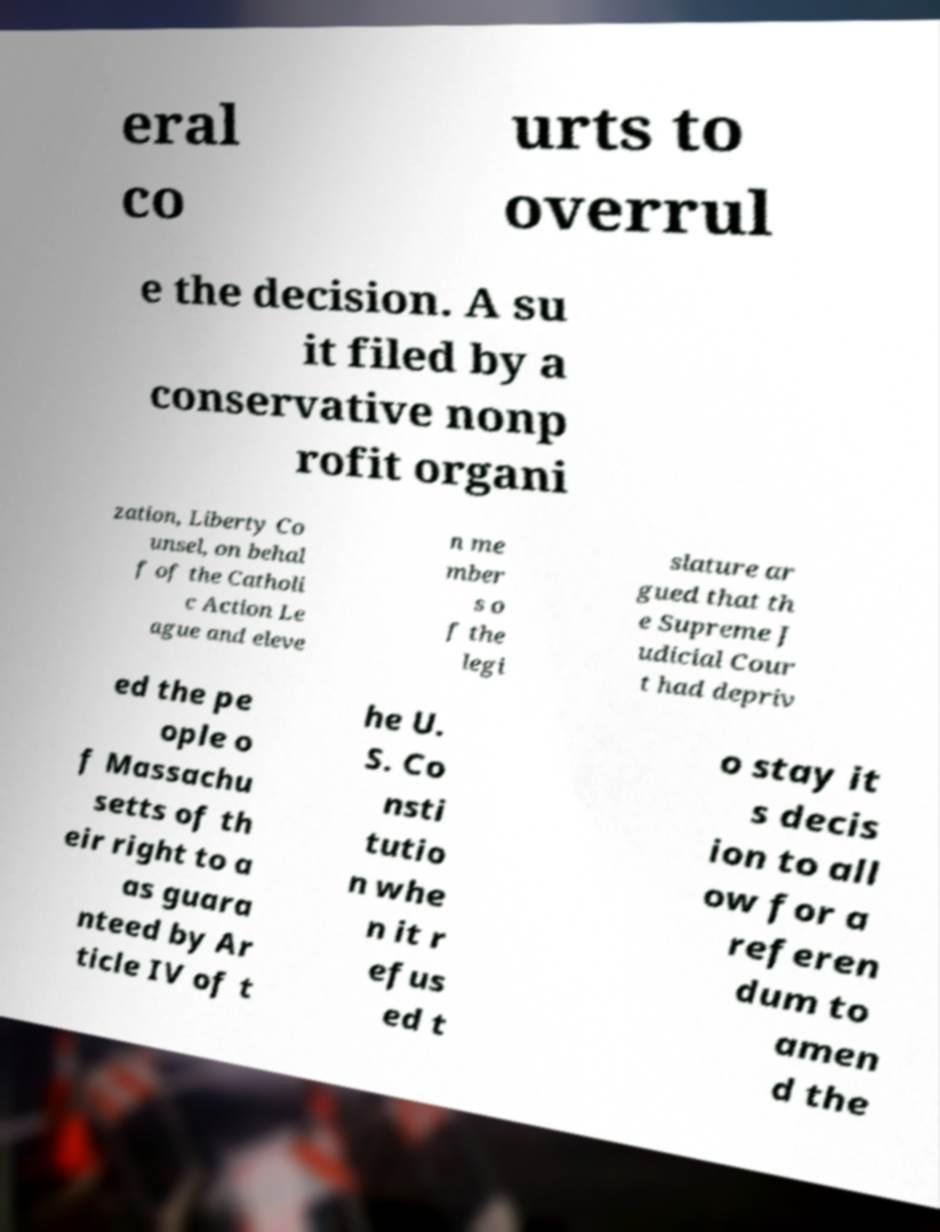I need the written content from this picture converted into text. Can you do that? eral co urts to overrul e the decision. A su it filed by a conservative nonp rofit organi zation, Liberty Co unsel, on behal f of the Catholi c Action Le ague and eleve n me mber s o f the legi slature ar gued that th e Supreme J udicial Cour t had depriv ed the pe ople o f Massachu setts of th eir right to a as guara nteed by Ar ticle IV of t he U. S. Co nsti tutio n whe n it r efus ed t o stay it s decis ion to all ow for a referen dum to amen d the 